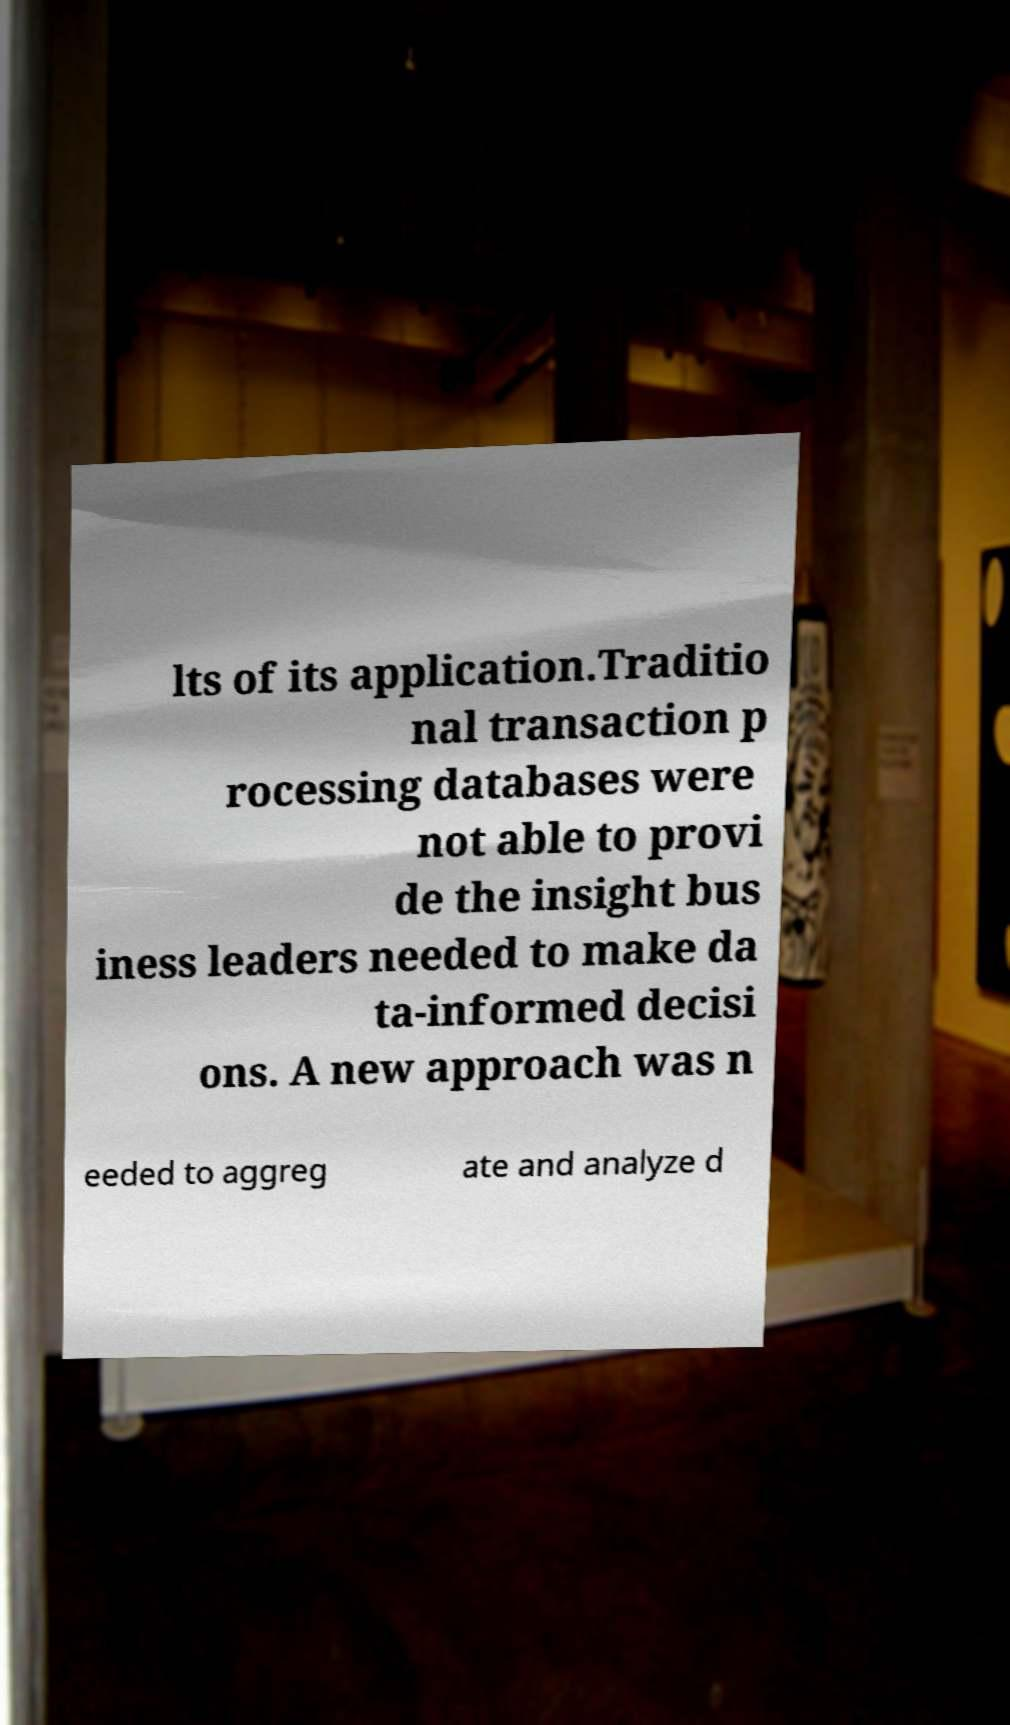Please read and relay the text visible in this image. What does it say? lts of its application.Traditio nal transaction p rocessing databases were not able to provi de the insight bus iness leaders needed to make da ta-informed decisi ons. A new approach was n eeded to aggreg ate and analyze d 